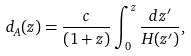<formula> <loc_0><loc_0><loc_500><loc_500>d _ { A } ( z ) = \frac { c } { \left ( 1 + z \right ) } \int _ { 0 } ^ { z } \frac { d z ^ { \prime } } { H ( z ^ { \prime } ) } ,</formula> 